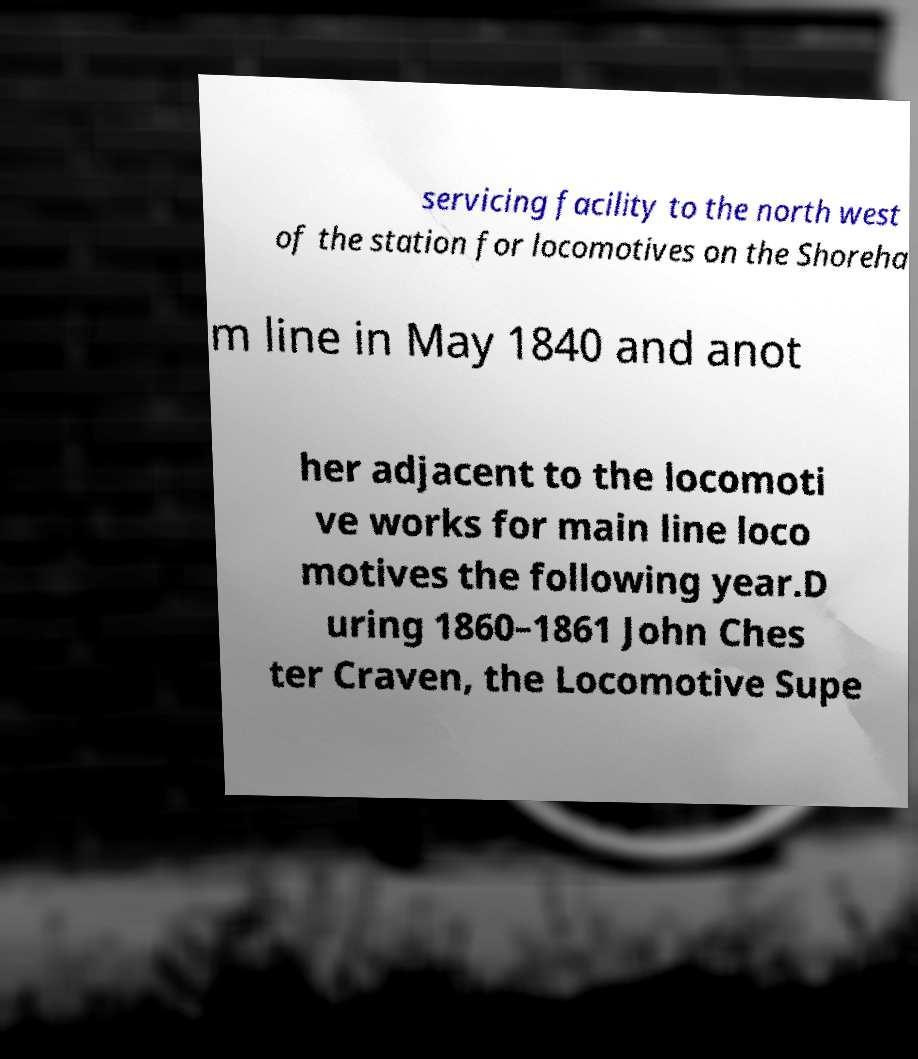Please read and relay the text visible in this image. What does it say? servicing facility to the north west of the station for locomotives on the Shoreha m line in May 1840 and anot her adjacent to the locomoti ve works for main line loco motives the following year.D uring 1860–1861 John Ches ter Craven, the Locomotive Supe 